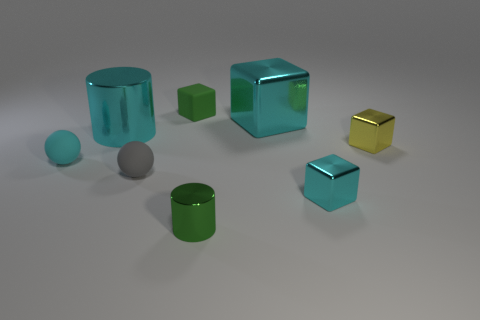Subtract all yellow blocks. How many blocks are left? 3 Subtract all blue cubes. Subtract all yellow cylinders. How many cubes are left? 4 Add 1 gray spheres. How many objects exist? 9 Subtract all spheres. How many objects are left? 6 Add 4 big cyan things. How many big cyan things are left? 6 Add 1 small rubber balls. How many small rubber balls exist? 3 Subtract 0 gray cubes. How many objects are left? 8 Subtract all small green metal things. Subtract all large blue shiny blocks. How many objects are left? 7 